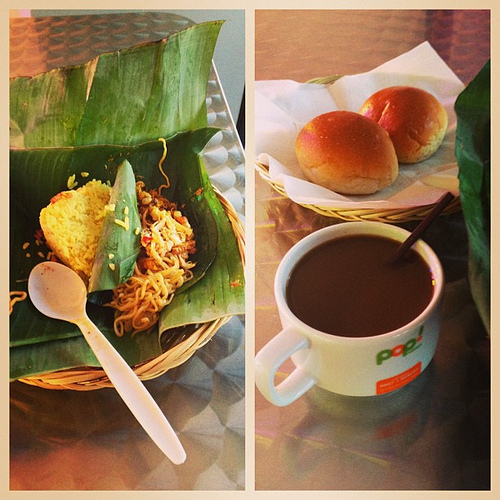What kind of baked good is in the basket that is on the table? Residing in the basket upon the table are buns, their golden-brown crusts promising a delightful texture and taste. 